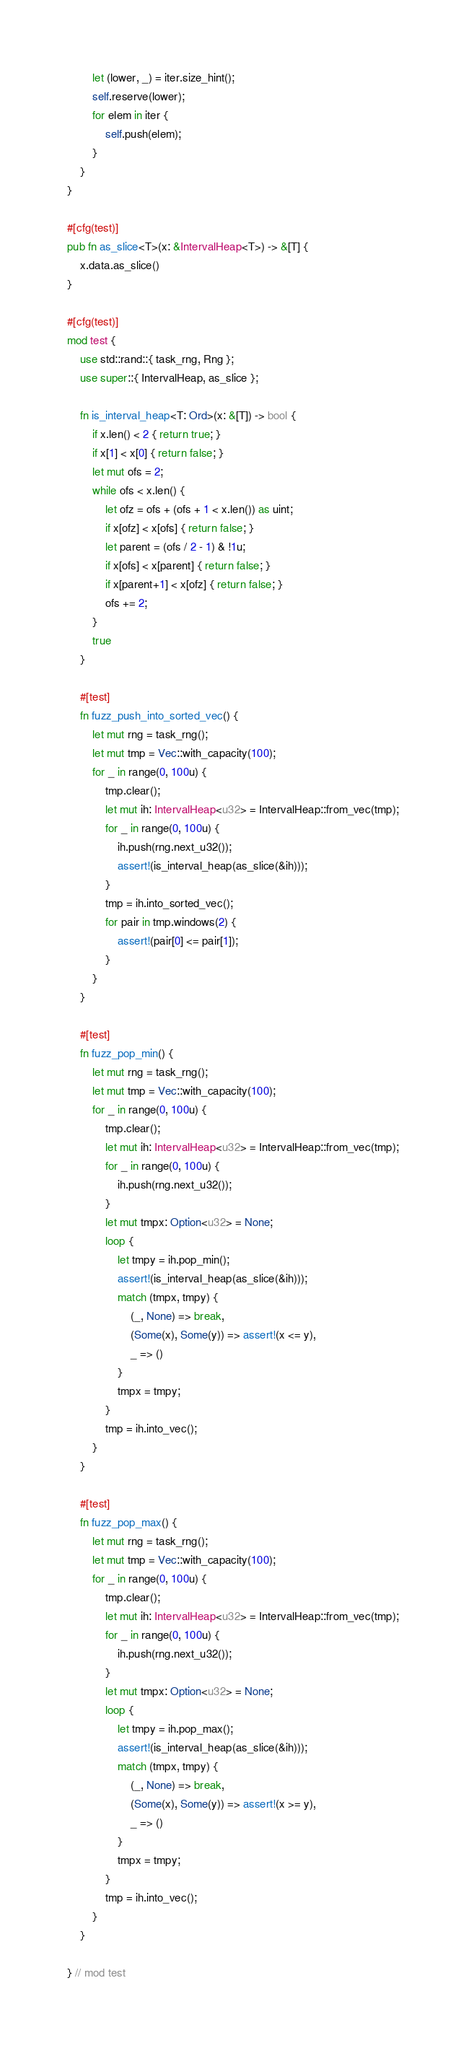<code> <loc_0><loc_0><loc_500><loc_500><_Rust_>        let (lower, _) = iter.size_hint();
        self.reserve(lower);
        for elem in iter {
            self.push(elem);
        }
    }
}

#[cfg(test)]
pub fn as_slice<T>(x: &IntervalHeap<T>) -> &[T] {
    x.data.as_slice()
}

#[cfg(test)]
mod test {
    use std::rand::{ task_rng, Rng };
    use super::{ IntervalHeap, as_slice };

    fn is_interval_heap<T: Ord>(x: &[T]) -> bool {
        if x.len() < 2 { return true; }
        if x[1] < x[0] { return false; }
        let mut ofs = 2;
        while ofs < x.len() {
            let ofz = ofs + (ofs + 1 < x.len()) as uint;
            if x[ofz] < x[ofs] { return false; }
            let parent = (ofs / 2 - 1) & !1u;
            if x[ofs] < x[parent] { return false; }
            if x[parent+1] < x[ofz] { return false; }
            ofs += 2;
        }
        true
    }

    #[test]
    fn fuzz_push_into_sorted_vec() {
        let mut rng = task_rng();
        let mut tmp = Vec::with_capacity(100);
        for _ in range(0, 100u) {
            tmp.clear();
            let mut ih: IntervalHeap<u32> = IntervalHeap::from_vec(tmp);
            for _ in range(0, 100u) {
                ih.push(rng.next_u32());
                assert!(is_interval_heap(as_slice(&ih)));
            }
            tmp = ih.into_sorted_vec();
            for pair in tmp.windows(2) {
                assert!(pair[0] <= pair[1]);
            }
        }
    }

    #[test]
    fn fuzz_pop_min() {
        let mut rng = task_rng();
        let mut tmp = Vec::with_capacity(100);
        for _ in range(0, 100u) {
            tmp.clear();
            let mut ih: IntervalHeap<u32> = IntervalHeap::from_vec(tmp);
            for _ in range(0, 100u) {
                ih.push(rng.next_u32());
            }
            let mut tmpx: Option<u32> = None;
            loop {
                let tmpy = ih.pop_min();
                assert!(is_interval_heap(as_slice(&ih)));
                match (tmpx, tmpy) {
                    (_, None) => break,
                    (Some(x), Some(y)) => assert!(x <= y),
                    _ => ()
                }
                tmpx = tmpy;
            }
            tmp = ih.into_vec();
        }
    }

    #[test]
    fn fuzz_pop_max() {
        let mut rng = task_rng();
        let mut tmp = Vec::with_capacity(100);
        for _ in range(0, 100u) {
            tmp.clear();
            let mut ih: IntervalHeap<u32> = IntervalHeap::from_vec(tmp);
            for _ in range(0, 100u) {
                ih.push(rng.next_u32());
            }
            let mut tmpx: Option<u32> = None;
            loop {
                let tmpy = ih.pop_max();
                assert!(is_interval_heap(as_slice(&ih)));
                match (tmpx, tmpy) {
                    (_, None) => break,
                    (Some(x), Some(y)) => assert!(x >= y),
                    _ => ()
                }
                tmpx = tmpy;
            }
            tmp = ih.into_vec();
        }
    }

} // mod test

</code> 